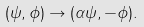Convert formula to latex. <formula><loc_0><loc_0><loc_500><loc_500>( \psi , \phi ) \rightarrow ( \alpha \psi , - \phi ) .</formula> 